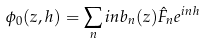Convert formula to latex. <formula><loc_0><loc_0><loc_500><loc_500>\phi _ { 0 } ( z , h ) = \sum _ { n } i n b _ { n } ( z ) \hat { F } _ { n } e ^ { i n h }</formula> 